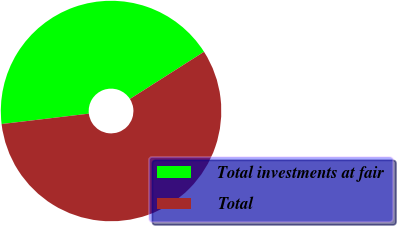Convert chart. <chart><loc_0><loc_0><loc_500><loc_500><pie_chart><fcel>Total investments at fair<fcel>Total<nl><fcel>42.86%<fcel>57.14%<nl></chart> 